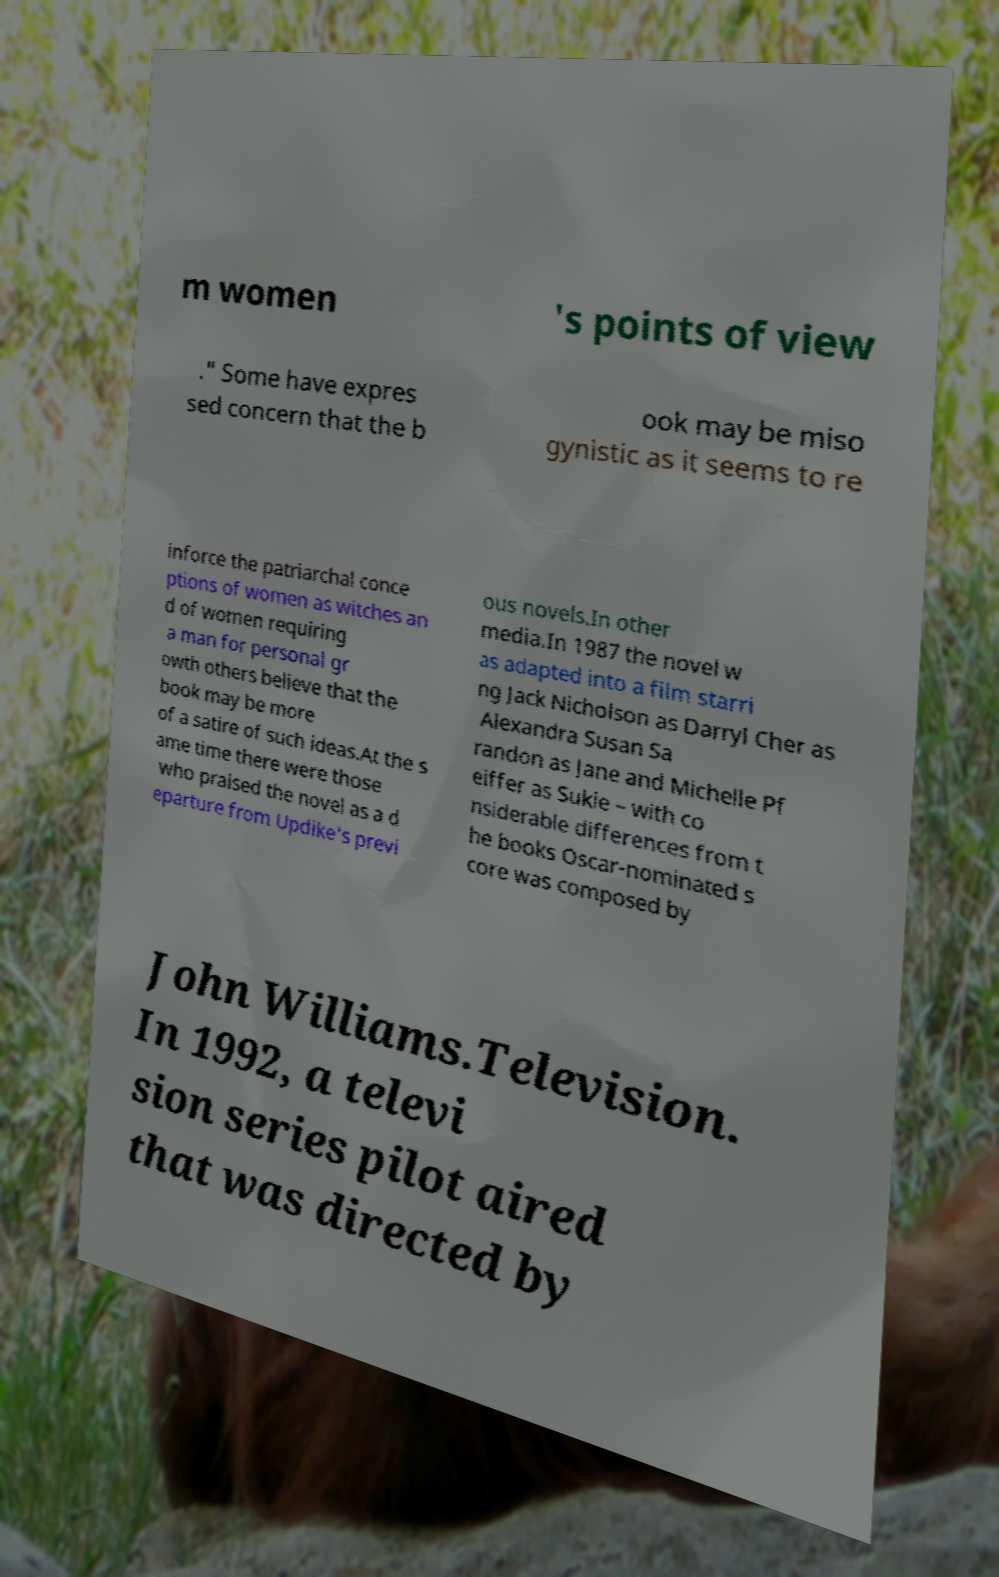What messages or text are displayed in this image? I need them in a readable, typed format. m women 's points of view ." Some have expres sed concern that the b ook may be miso gynistic as it seems to re inforce the patriarchal conce ptions of women as witches an d of women requiring a man for personal gr owth others believe that the book may be more of a satire of such ideas.At the s ame time there were those who praised the novel as a d eparture from Updike's previ ous novels.In other media.In 1987 the novel w as adapted into a film starri ng Jack Nicholson as Darryl Cher as Alexandra Susan Sa randon as Jane and Michelle Pf eiffer as Sukie – with co nsiderable differences from t he books Oscar-nominated s core was composed by John Williams.Television. In 1992, a televi sion series pilot aired that was directed by 